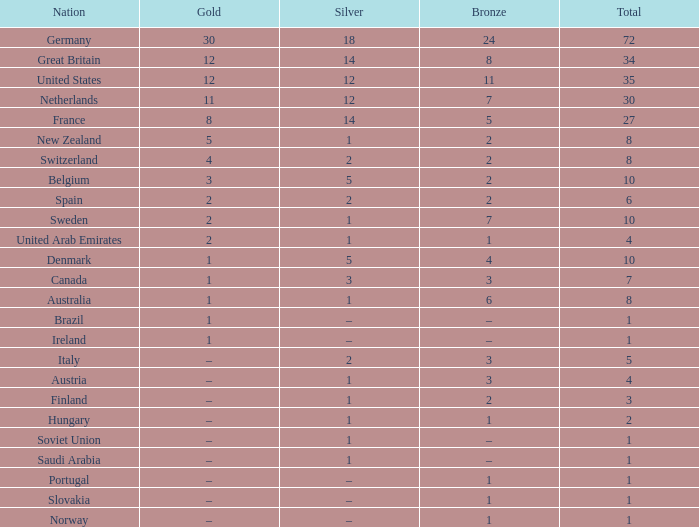What is the total number of Total, when Silver is 1, and when Bronze is 7? 1.0. 